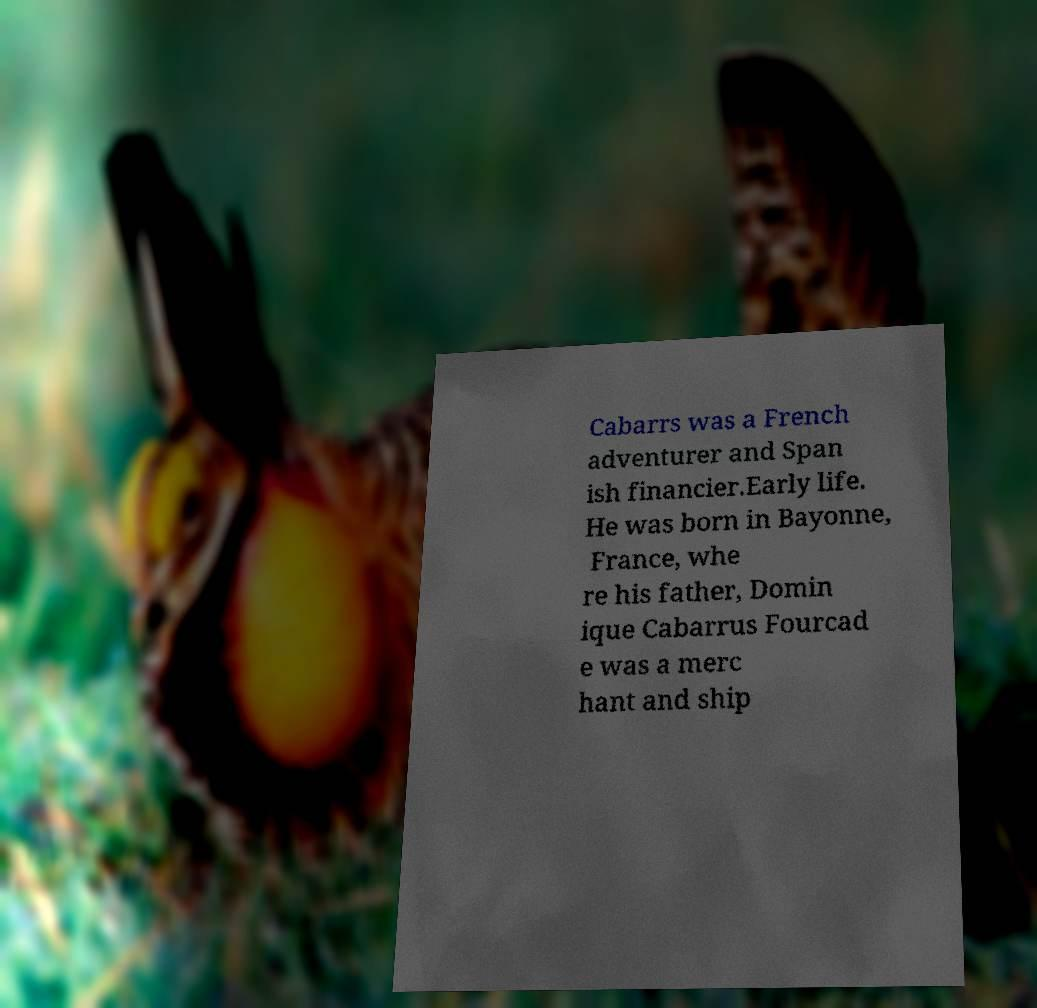Can you read and provide the text displayed in the image?This photo seems to have some interesting text. Can you extract and type it out for me? Cabarrs was a French adventurer and Span ish financier.Early life. He was born in Bayonne, France, whe re his father, Domin ique Cabarrus Fourcad e was a merc hant and ship 